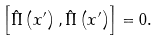<formula> <loc_0><loc_0><loc_500><loc_500>\left [ \hat { \Pi } \left ( x ^ { \prime } \right ) , \hat { \Pi } \left ( x ^ { \prime } \right ) \right ] = 0 .</formula> 